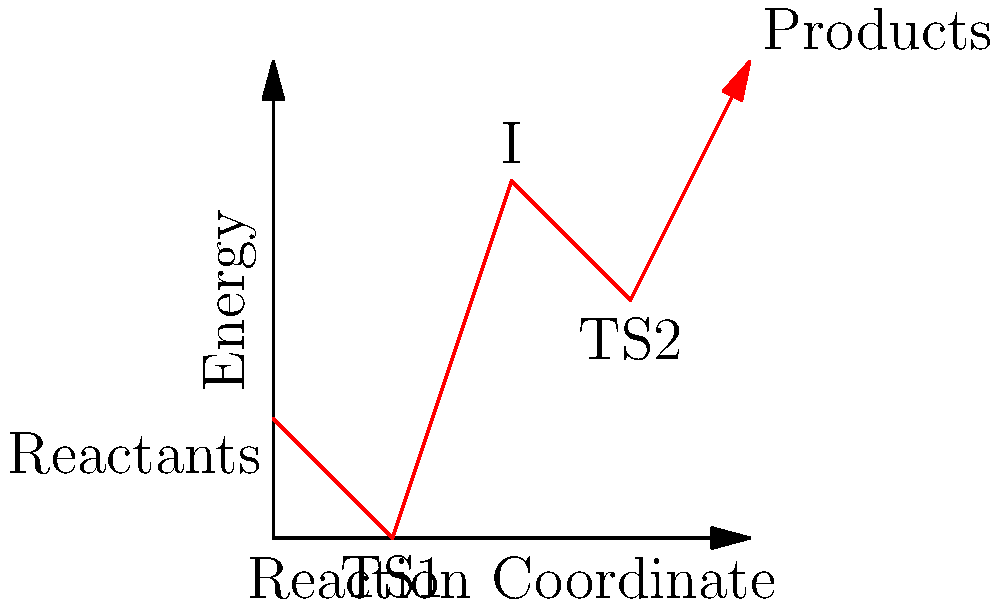Consider the energy profile diagram for a chemical reaction shown above. Using group theory principles, determine the symmetry group of the transition state TS2 if it belongs to the point group $D_{3h}$. What is the order of this group? To solve this problem, we need to apply group theory concepts to the given chemical reaction energy profile:

1. Identify the point group: The question states that TS2 belongs to the point group $D_{3h}$.

2. Understand the symmetry elements of $D_{3h}$:
   - One $C_3$ axis (3-fold rotation)
   - Three $C_2$ axes perpendicular to the $C_3$ axis
   - One $\sigma_h$ plane (horizontal mirror plane)
   - Three $\sigma_v$ planes (vertical mirror planes)
   - $S_3$ improper rotation axis

3. Count the symmetry operations:
   - Identity operation (E): 1
   - $C_3$ rotations: 2 ($C_3$ and $C_3^2$)
   - $C_2$ rotations: 3
   - $\sigma_h$ reflection: 1
   - $\sigma_v$ reflections: 3
   - $S_3$ improper rotations: 2 ($S_3$ and $S_3^5$)

4. Calculate the order of the group:
   The order of a group is the total number of symmetry operations.
   Order = 1 + 2 + 3 + 1 + 3 + 2 = 12

Therefore, the symmetry group of TS2 is $D_{3h}$, and its order is 12.
Answer: $D_{3h}$, order 12 